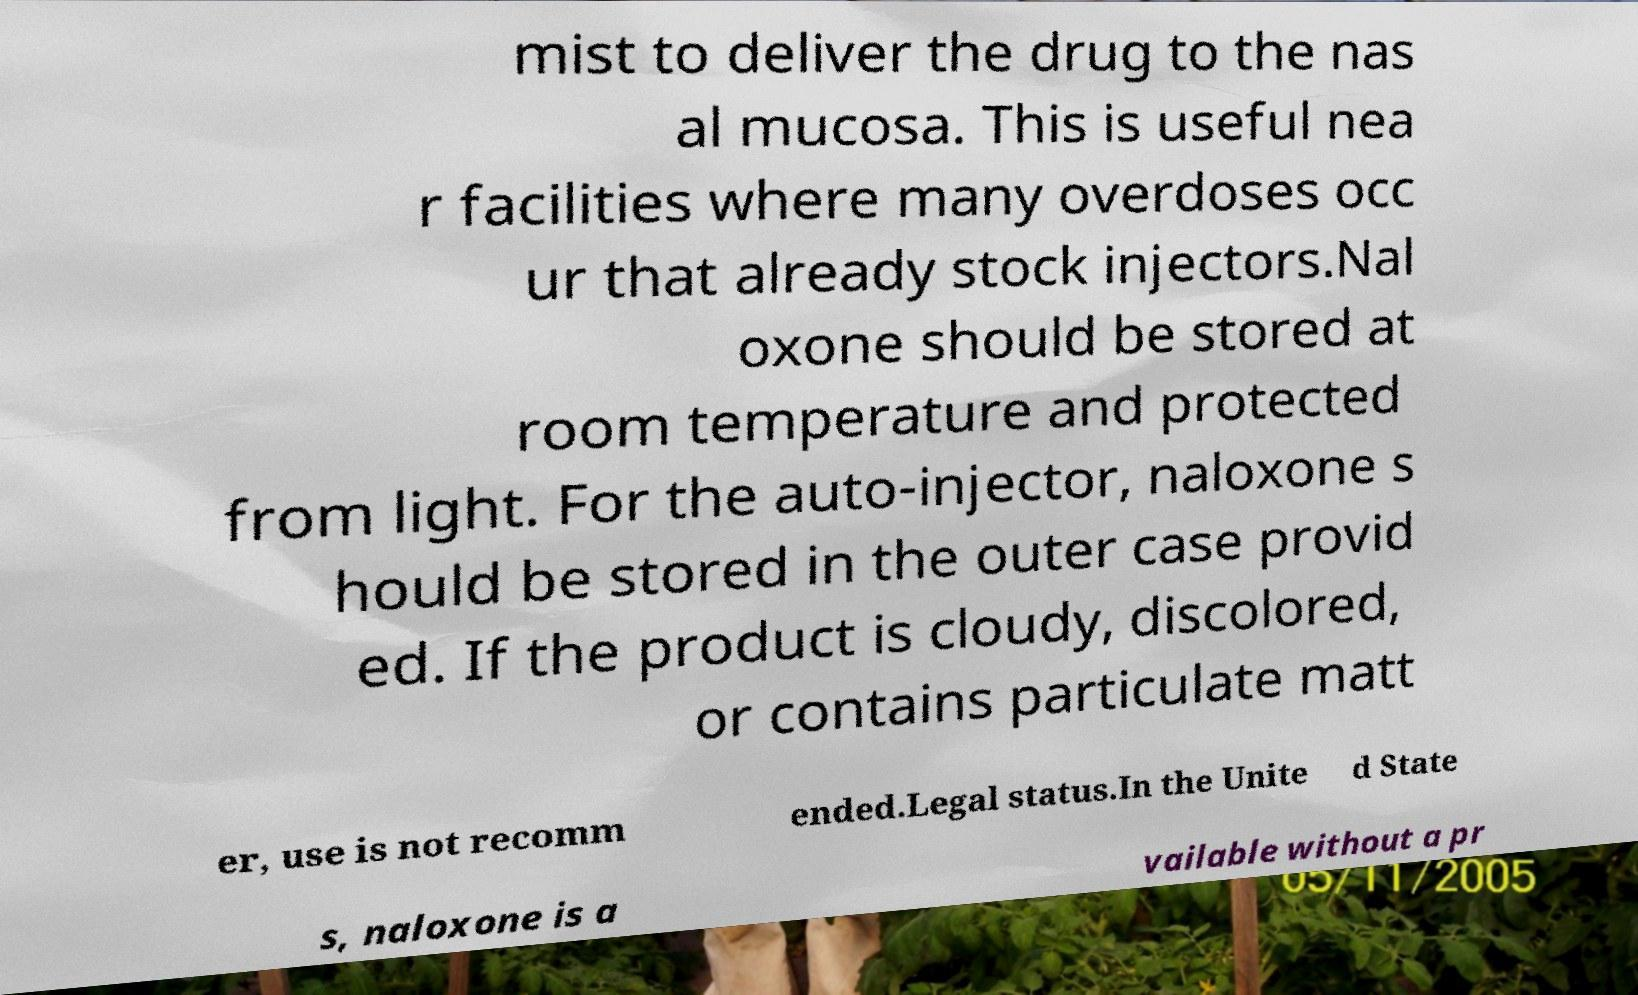Could you assist in decoding the text presented in this image and type it out clearly? mist to deliver the drug to the nas al mucosa. This is useful nea r facilities where many overdoses occ ur that already stock injectors.Nal oxone should be stored at room temperature and protected from light. For the auto-injector, naloxone s hould be stored in the outer case provid ed. If the product is cloudy, discolored, or contains particulate matt er, use is not recomm ended.Legal status.In the Unite d State s, naloxone is a vailable without a pr 